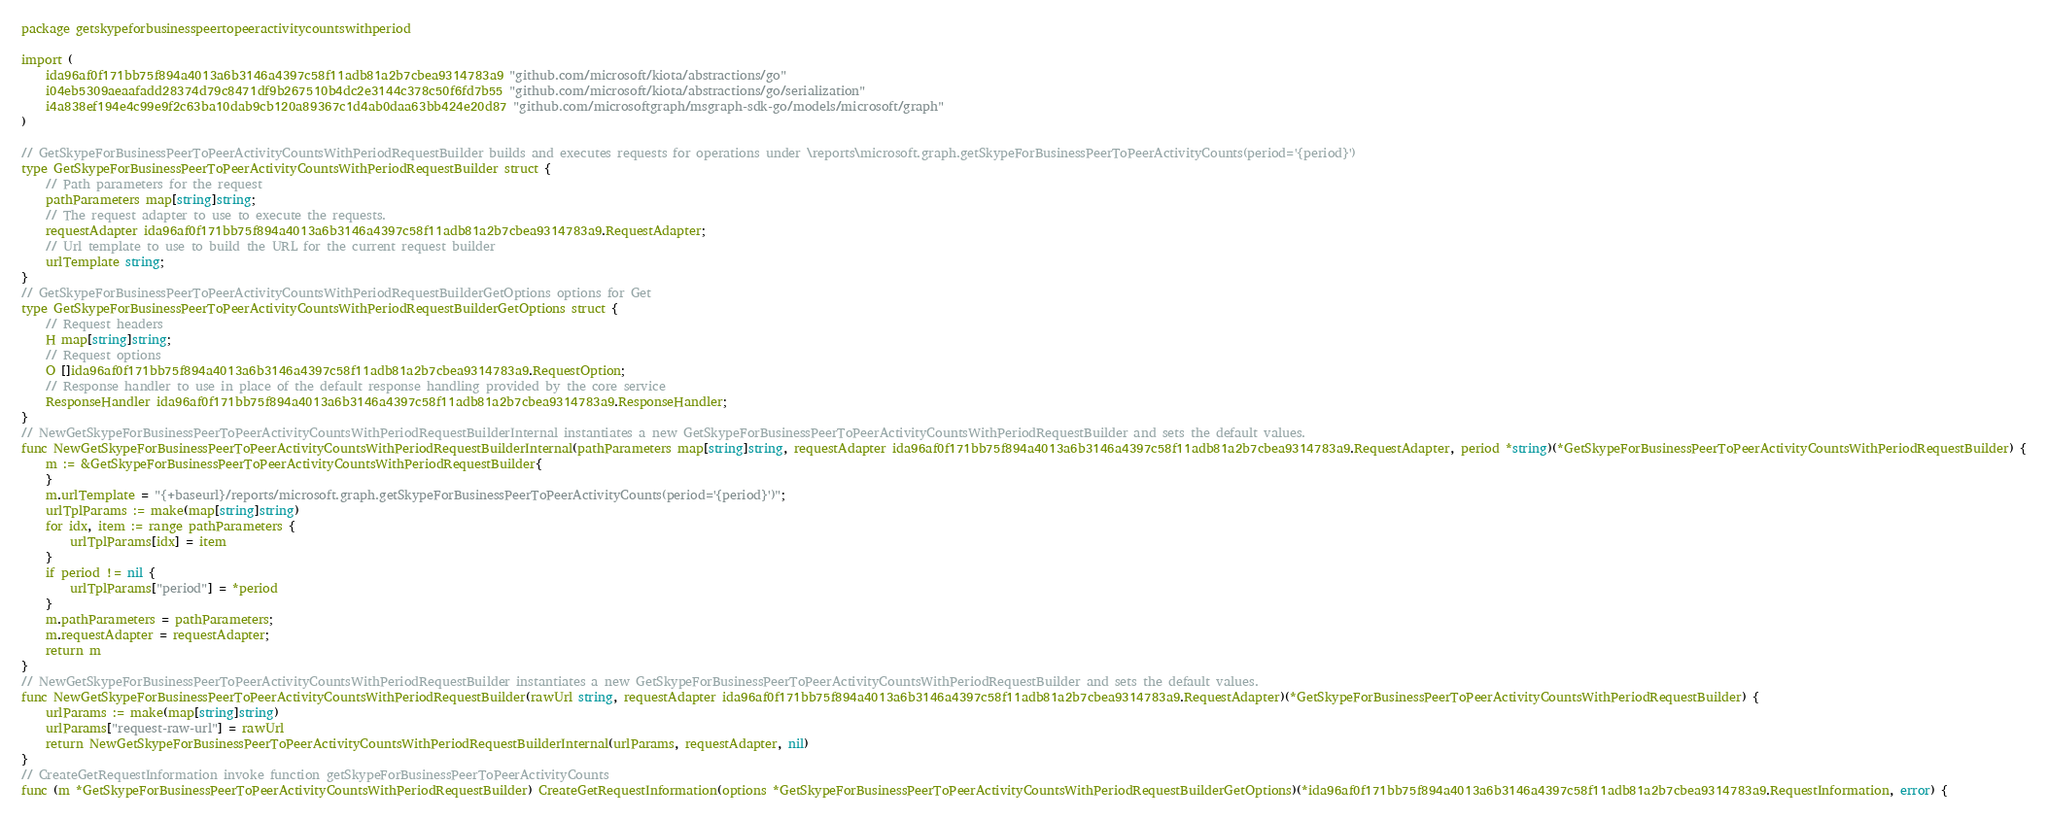Convert code to text. <code><loc_0><loc_0><loc_500><loc_500><_Go_>package getskypeforbusinesspeertopeeractivitycountswithperiod

import (
    ida96af0f171bb75f894a4013a6b3146a4397c58f11adb81a2b7cbea9314783a9 "github.com/microsoft/kiota/abstractions/go"
    i04eb5309aeaafadd28374d79c8471df9b267510b4dc2e3144c378c50f6fd7b55 "github.com/microsoft/kiota/abstractions/go/serialization"
    i4a838ef194e4c99e9f2c63ba10dab9cb120a89367c1d4ab0daa63bb424e20d87 "github.com/microsoftgraph/msgraph-sdk-go/models/microsoft/graph"
)

// GetSkypeForBusinessPeerToPeerActivityCountsWithPeriodRequestBuilder builds and executes requests for operations under \reports\microsoft.graph.getSkypeForBusinessPeerToPeerActivityCounts(period='{period}')
type GetSkypeForBusinessPeerToPeerActivityCountsWithPeriodRequestBuilder struct {
    // Path parameters for the request
    pathParameters map[string]string;
    // The request adapter to use to execute the requests.
    requestAdapter ida96af0f171bb75f894a4013a6b3146a4397c58f11adb81a2b7cbea9314783a9.RequestAdapter;
    // Url template to use to build the URL for the current request builder
    urlTemplate string;
}
// GetSkypeForBusinessPeerToPeerActivityCountsWithPeriodRequestBuilderGetOptions options for Get
type GetSkypeForBusinessPeerToPeerActivityCountsWithPeriodRequestBuilderGetOptions struct {
    // Request headers
    H map[string]string;
    // Request options
    O []ida96af0f171bb75f894a4013a6b3146a4397c58f11adb81a2b7cbea9314783a9.RequestOption;
    // Response handler to use in place of the default response handling provided by the core service
    ResponseHandler ida96af0f171bb75f894a4013a6b3146a4397c58f11adb81a2b7cbea9314783a9.ResponseHandler;
}
// NewGetSkypeForBusinessPeerToPeerActivityCountsWithPeriodRequestBuilderInternal instantiates a new GetSkypeForBusinessPeerToPeerActivityCountsWithPeriodRequestBuilder and sets the default values.
func NewGetSkypeForBusinessPeerToPeerActivityCountsWithPeriodRequestBuilderInternal(pathParameters map[string]string, requestAdapter ida96af0f171bb75f894a4013a6b3146a4397c58f11adb81a2b7cbea9314783a9.RequestAdapter, period *string)(*GetSkypeForBusinessPeerToPeerActivityCountsWithPeriodRequestBuilder) {
    m := &GetSkypeForBusinessPeerToPeerActivityCountsWithPeriodRequestBuilder{
    }
    m.urlTemplate = "{+baseurl}/reports/microsoft.graph.getSkypeForBusinessPeerToPeerActivityCounts(period='{period}')";
    urlTplParams := make(map[string]string)
    for idx, item := range pathParameters {
        urlTplParams[idx] = item
    }
    if period != nil {
        urlTplParams["period"] = *period
    }
    m.pathParameters = pathParameters;
    m.requestAdapter = requestAdapter;
    return m
}
// NewGetSkypeForBusinessPeerToPeerActivityCountsWithPeriodRequestBuilder instantiates a new GetSkypeForBusinessPeerToPeerActivityCountsWithPeriodRequestBuilder and sets the default values.
func NewGetSkypeForBusinessPeerToPeerActivityCountsWithPeriodRequestBuilder(rawUrl string, requestAdapter ida96af0f171bb75f894a4013a6b3146a4397c58f11adb81a2b7cbea9314783a9.RequestAdapter)(*GetSkypeForBusinessPeerToPeerActivityCountsWithPeriodRequestBuilder) {
    urlParams := make(map[string]string)
    urlParams["request-raw-url"] = rawUrl
    return NewGetSkypeForBusinessPeerToPeerActivityCountsWithPeriodRequestBuilderInternal(urlParams, requestAdapter, nil)
}
// CreateGetRequestInformation invoke function getSkypeForBusinessPeerToPeerActivityCounts
func (m *GetSkypeForBusinessPeerToPeerActivityCountsWithPeriodRequestBuilder) CreateGetRequestInformation(options *GetSkypeForBusinessPeerToPeerActivityCountsWithPeriodRequestBuilderGetOptions)(*ida96af0f171bb75f894a4013a6b3146a4397c58f11adb81a2b7cbea9314783a9.RequestInformation, error) {</code> 